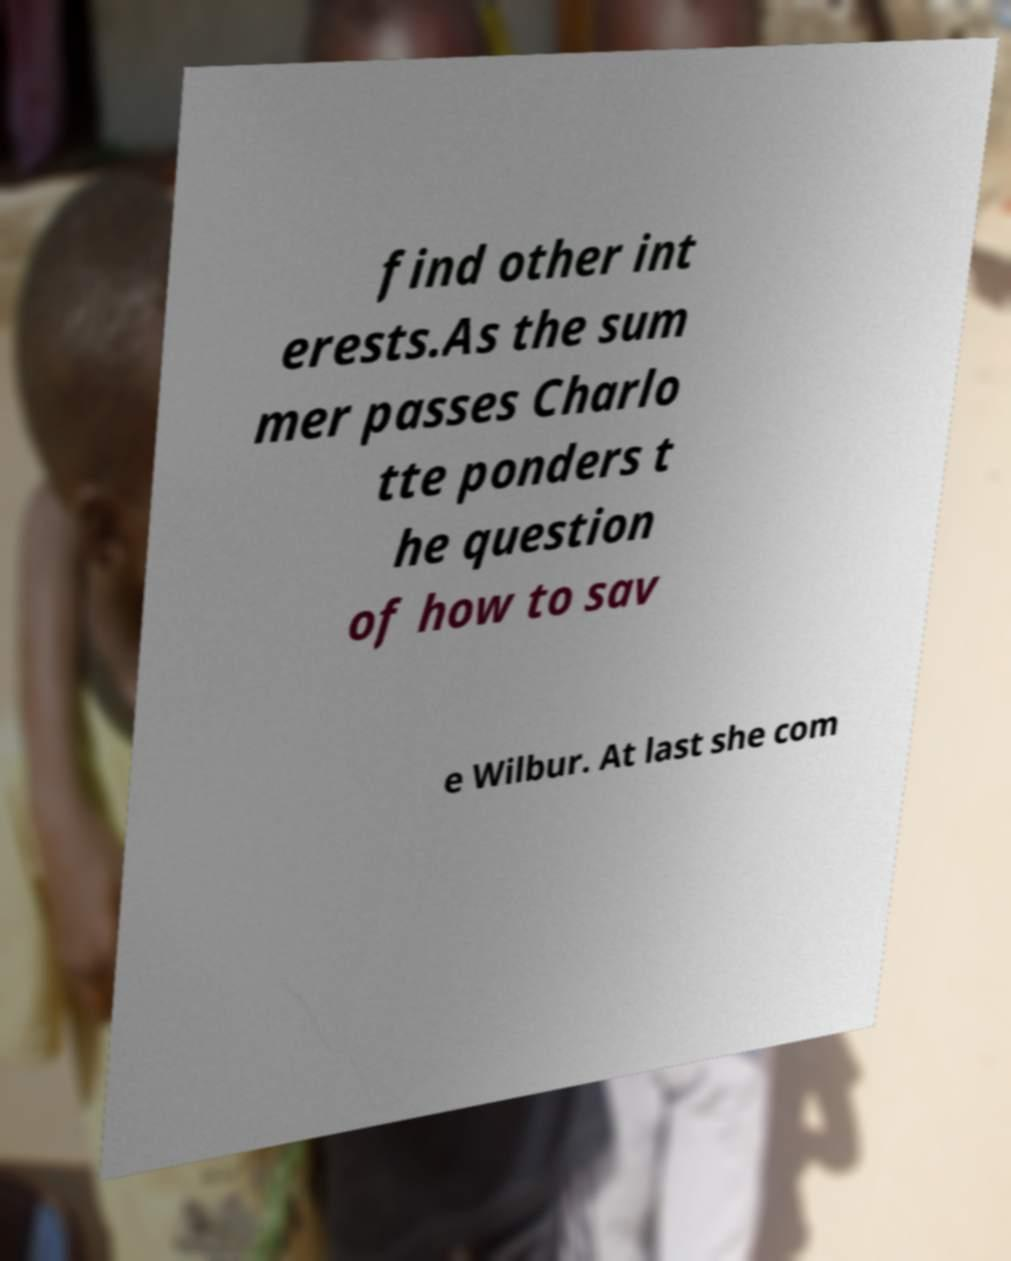Please identify and transcribe the text found in this image. find other int erests.As the sum mer passes Charlo tte ponders t he question of how to sav e Wilbur. At last she com 